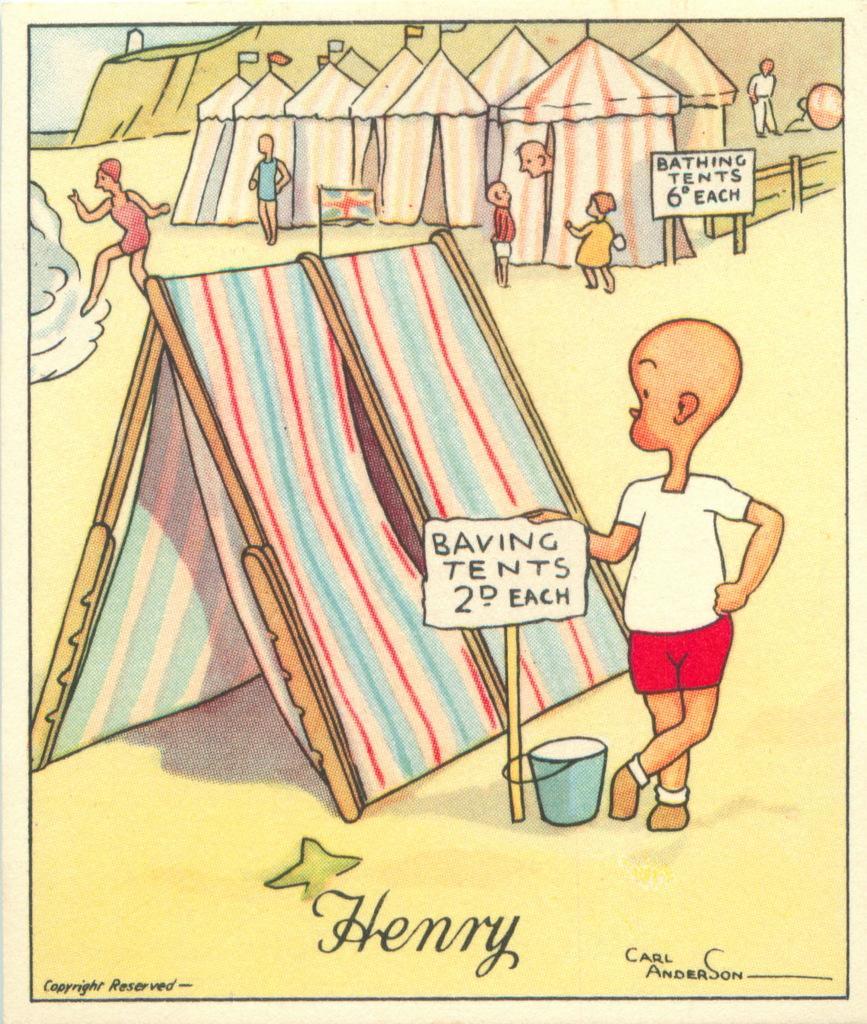In one or two sentences, can you explain what this image depicts? This image is a drawing. In this image we can tents. There are kids. At the bottom of the image there is some text. 